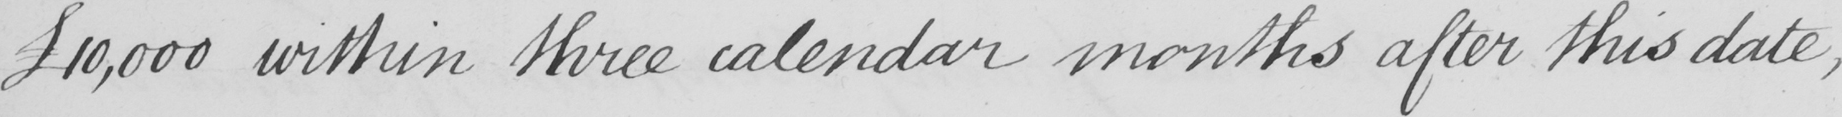What text is written in this handwritten line? £10,000 within three calendar months after this date , 